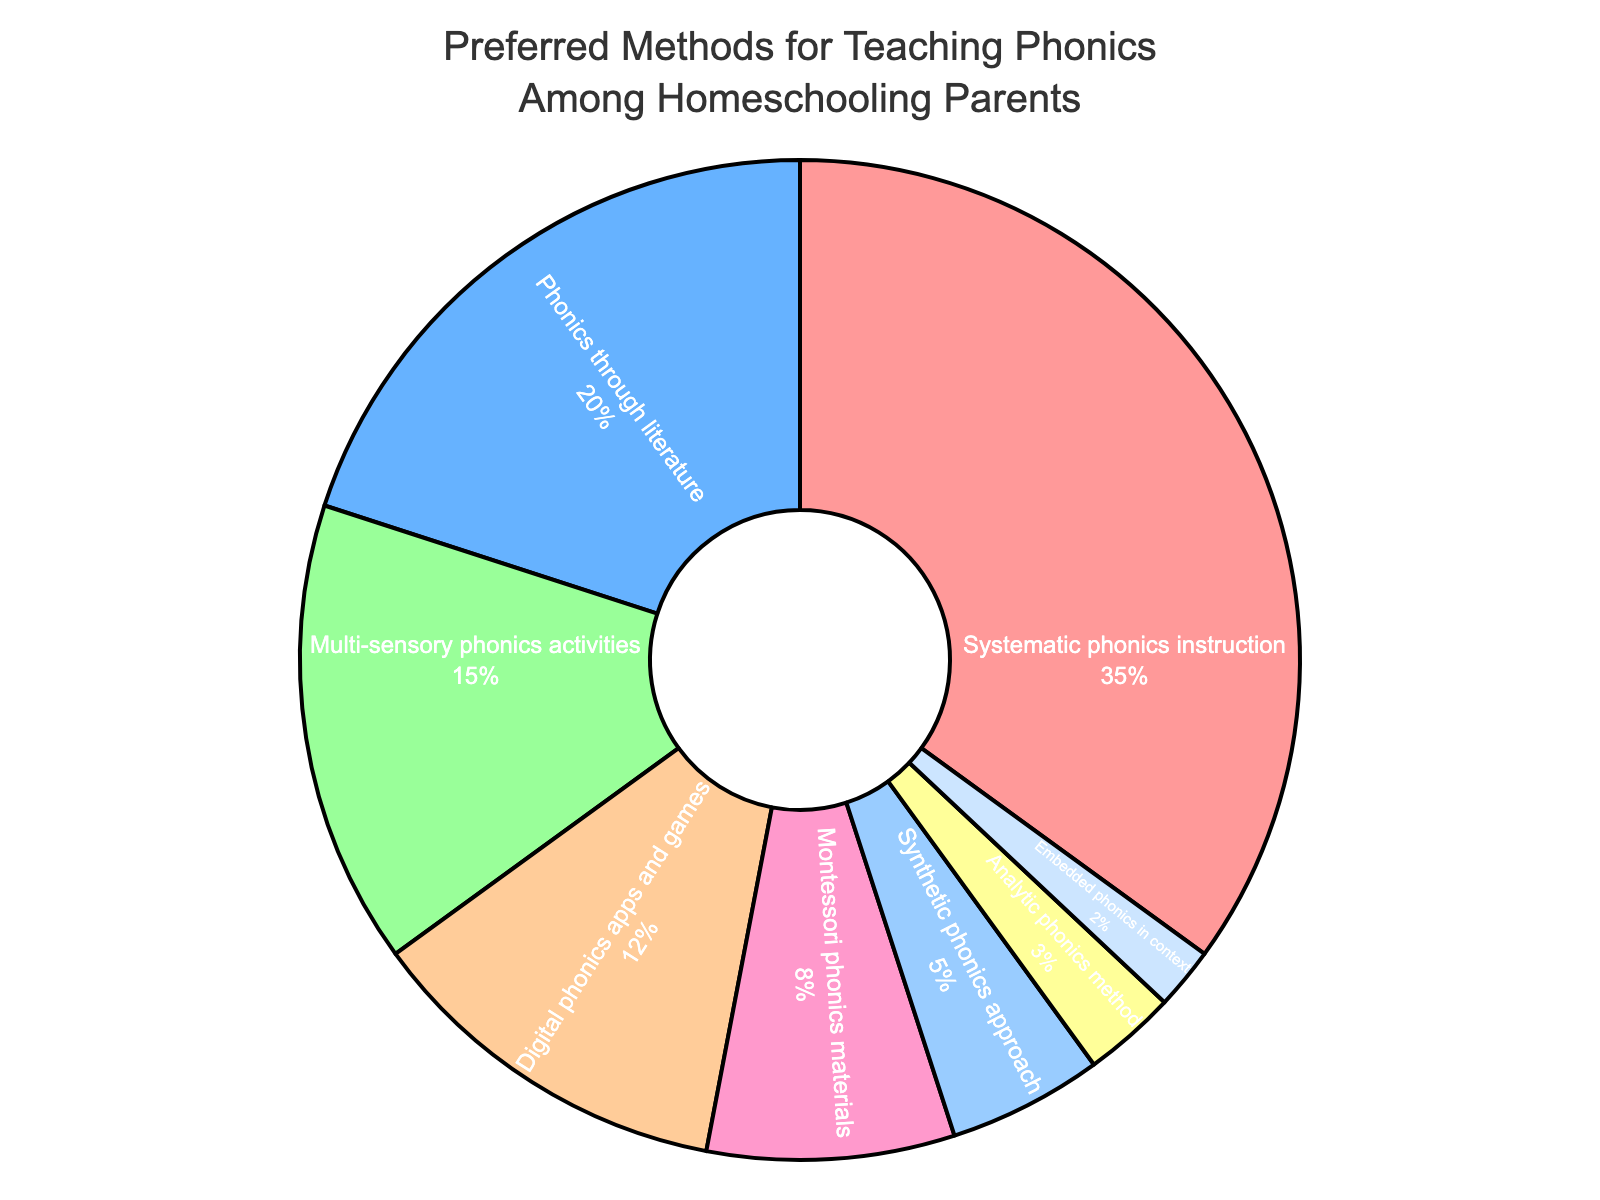What is the most preferred method for teaching phonics among homeschooling parents? According to the pie chart, the segment representing "Systematic phonics instruction" is the largest, indicating that it is the most preferred method.
Answer: Systematic phonics instruction Comparatively, how much more preferred is "Systematic phonics instruction" over "Analytic phonics method"? From the chart, "Systematic phonics instruction" has 35%, whereas "Analytic phonics method" has 3%. The difference is 35% - 3% = 32%.
Answer: 32% What percentage of parents prefer digital phonics apps and games over multi-sensory phonics activities? From the chart, "Digital phonics apps and games" account for 12% while "Multi-sensory phonics activities" make up 15%. To find the difference, subtract 12% from 15%, which equals 3%.
Answer: 3% If you combine "Phonics through literature" and "Montessori phonics materials", what is the total percentage? "Phonics through literature" is 20% and "Montessori phonics materials" is 8%. Adding them together gives 20% + 8% = 28%.
Answer: 28% Which method is less preferred: "Phonics through literature" or "Synthetic phonics approach"? The pie chart shows "Phonics through literature" at 20% and "Synthetic phonics approach" at 5%. Since 5% is less than 20%, "Synthetic phonics approach" is less preferred.
Answer: Synthetic phonics approach Among the given methods, which one is the least preferred? The smallest segment in the pie chart is "Embedded phonics in context", representing 2%, making it the least preferred method.
Answer: Embedded phonics in context What is the combined percentage of all methods that are preferred by less than 10% of homeschooling parents? The methods under 10% are: "Montessori phonics materials" (8%), "Synthetic phonics approach" (5%), "Analytic phonics method" (3%), and "Embedded phonics in context" (2%). Adding these gives 8% + 5% + 3% + 2% = 18%.
Answer: 18% What visual color represents "Phonics through literature"? The pie chart shows "Phonics through literature" in the second segment which is colored blue.
Answer: Blue 